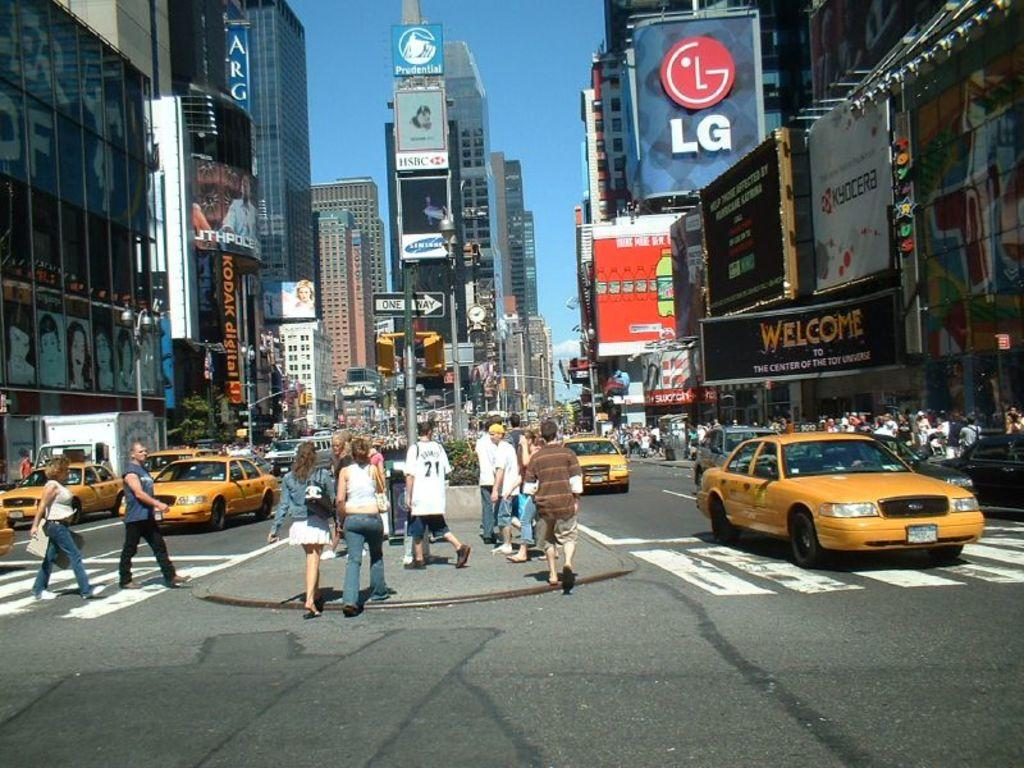Provide a one-sentence caption for the provided image. Many people and yellow cabs are seen on a street with large buildings and lots of advertising including LG, Kycoera, Kodak Digital, and Mountain Dew. 